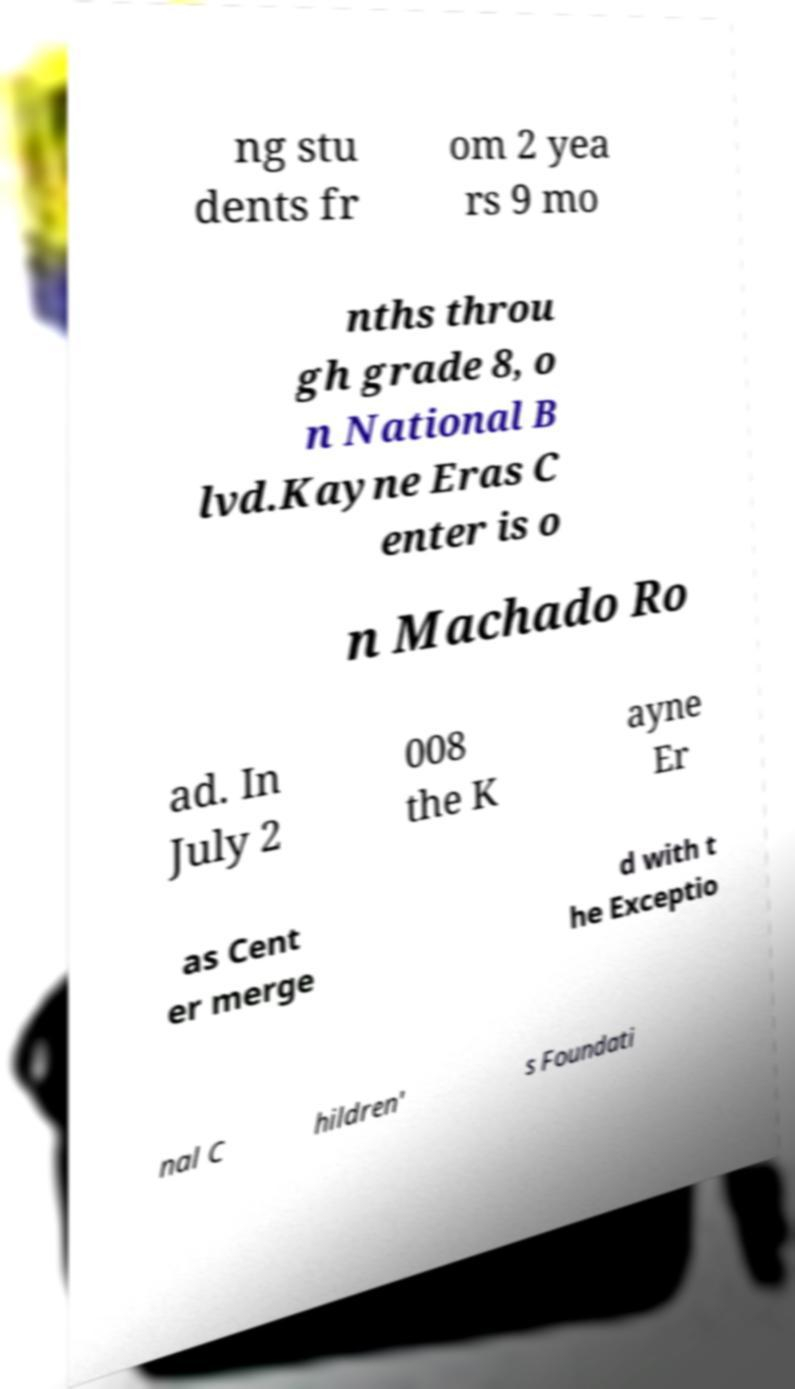Please identify and transcribe the text found in this image. ng stu dents fr om 2 yea rs 9 mo nths throu gh grade 8, o n National B lvd.Kayne Eras C enter is o n Machado Ro ad. In July 2 008 the K ayne Er as Cent er merge d with t he Exceptio nal C hildren' s Foundati 